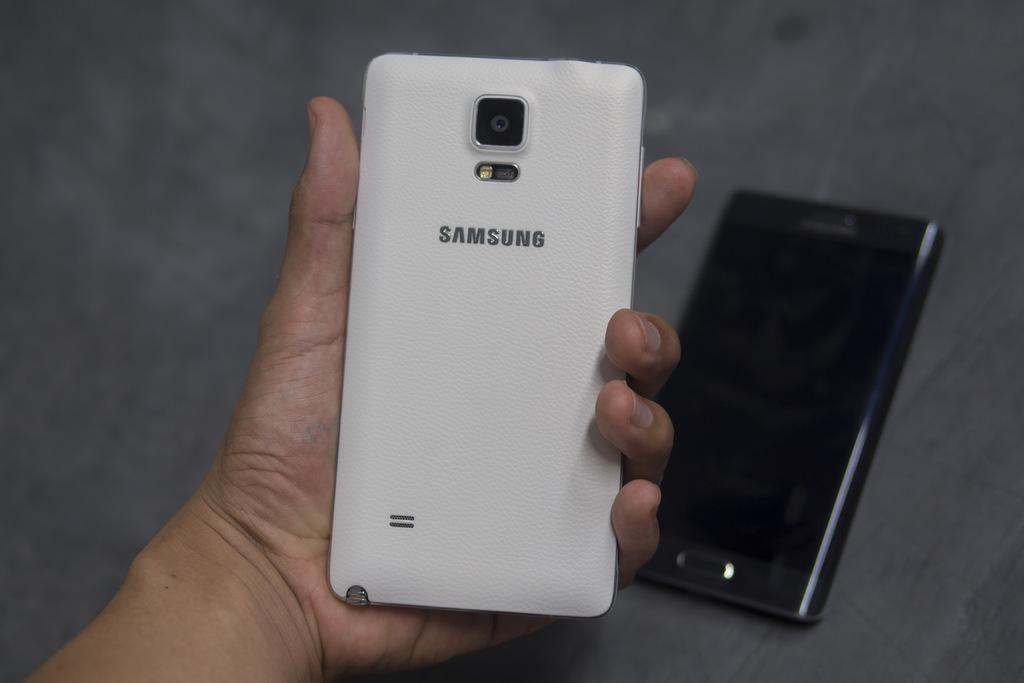<image>
Render a clear and concise summary of the photo. A white Samsung phone is held in a person's open hand and another phone sits on a table in the background. 